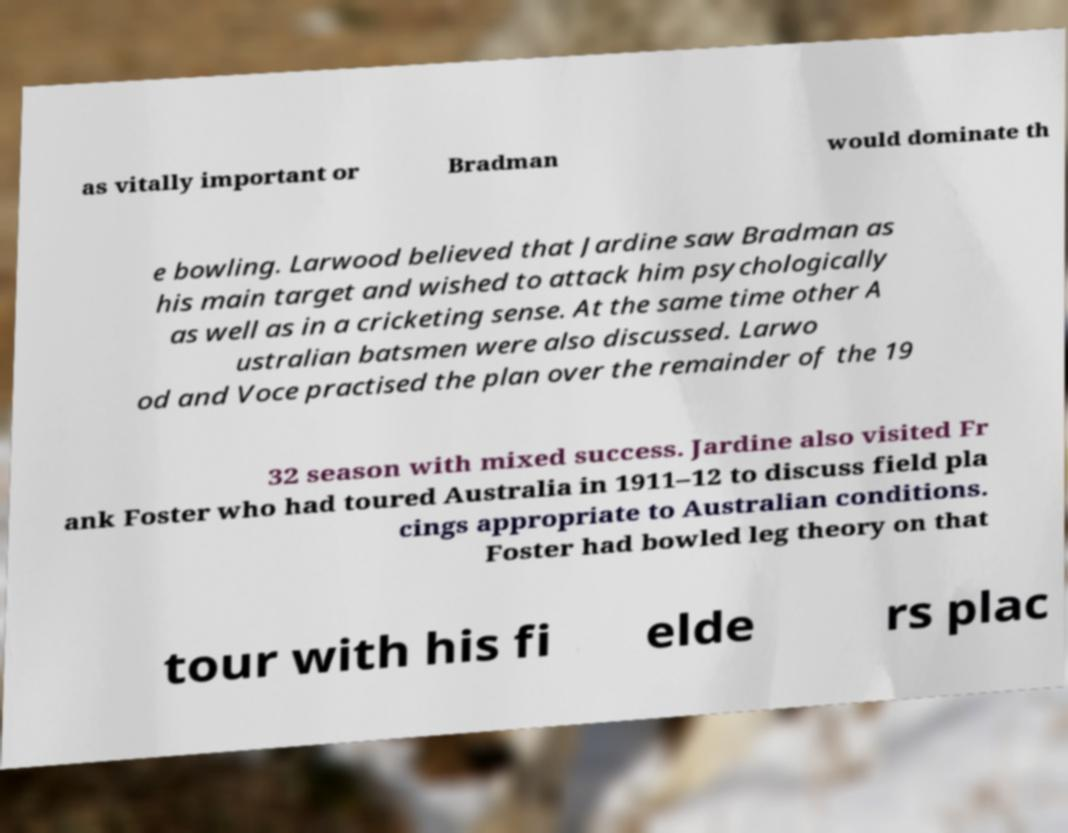Please read and relay the text visible in this image. What does it say? as vitally important or Bradman would dominate th e bowling. Larwood believed that Jardine saw Bradman as his main target and wished to attack him psychologically as well as in a cricketing sense. At the same time other A ustralian batsmen were also discussed. Larwo od and Voce practised the plan over the remainder of the 19 32 season with mixed success. Jardine also visited Fr ank Foster who had toured Australia in 1911–12 to discuss field pla cings appropriate to Australian conditions. Foster had bowled leg theory on that tour with his fi elde rs plac 